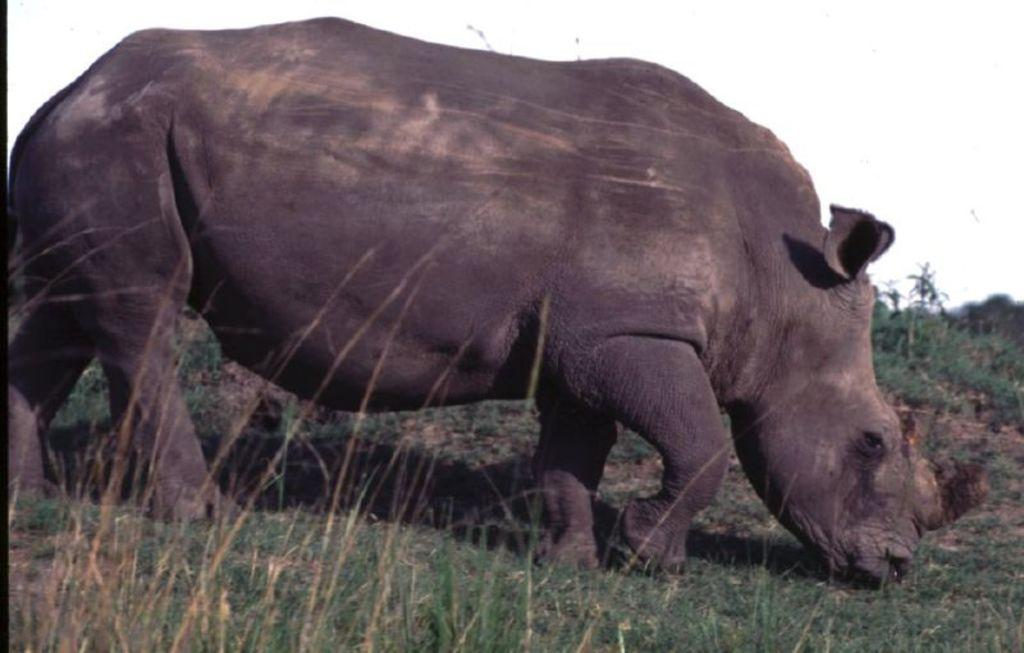What animal is present in the image? There is a rhinoceros in the image. What is the rhinoceros doing in the image? The rhinoceros is standing on the ground. What type of surface is the rhinoceros standing on? There is grass on the ground. What can be seen in the background on the right side of the image? There are plants in the background on the right side of the image. What type of chain is wrapped around the rhinoceros's neck in the image? There is no chain present in the image; the rhinoceros is not wearing any accessories. 